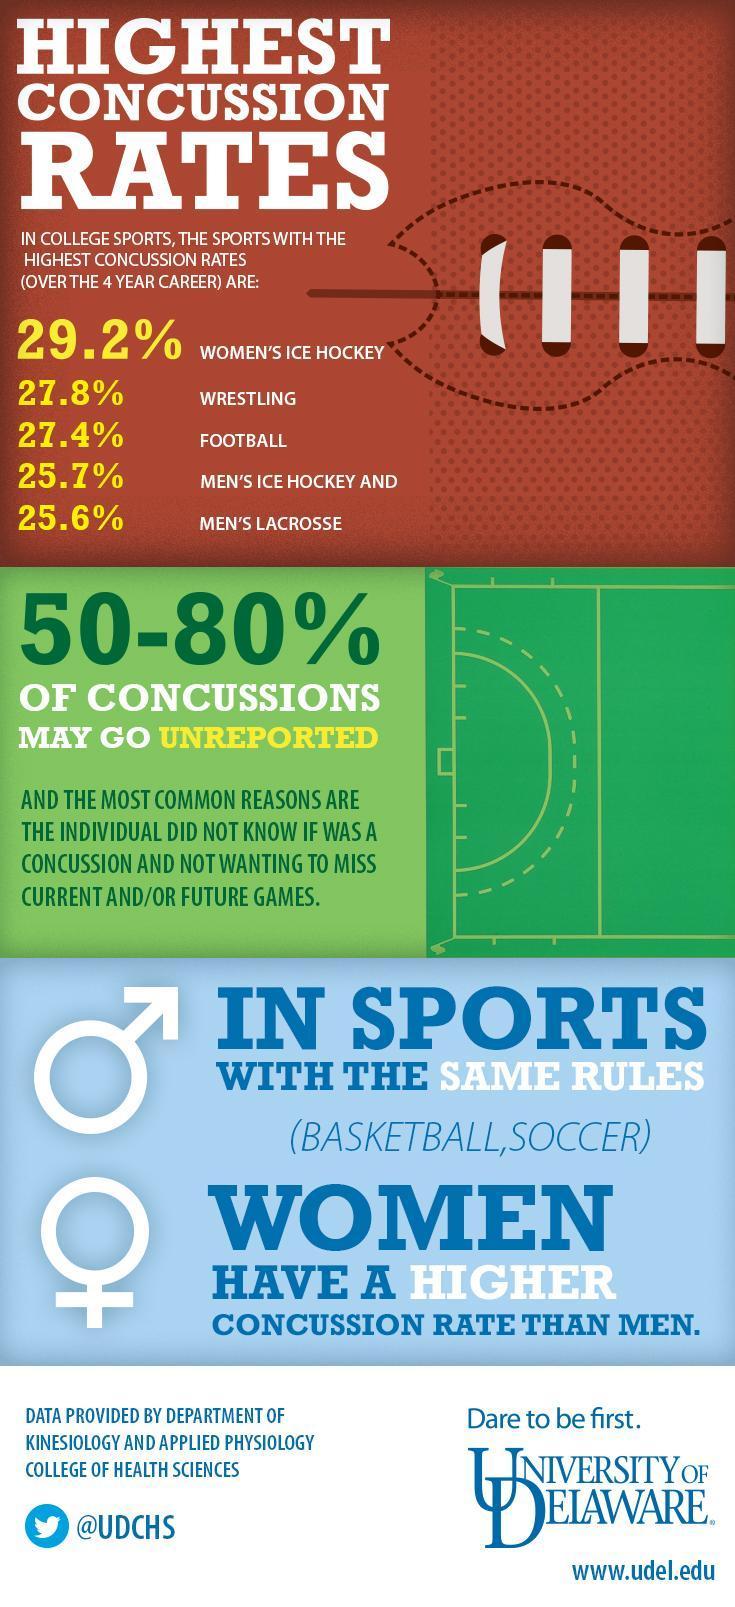In sports with same rules, which gender has a lower concussion rate?
Answer the question with a short phrase. MEN What is the Twitter handle given? @UDCHS In Ice hockey, which gender has a higher concussion rate? WOMEN 